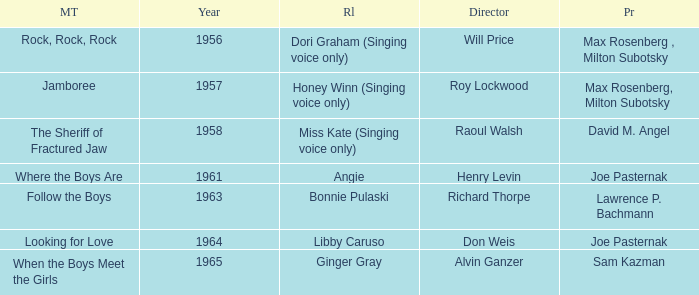What year was Jamboree made? 1957.0. 